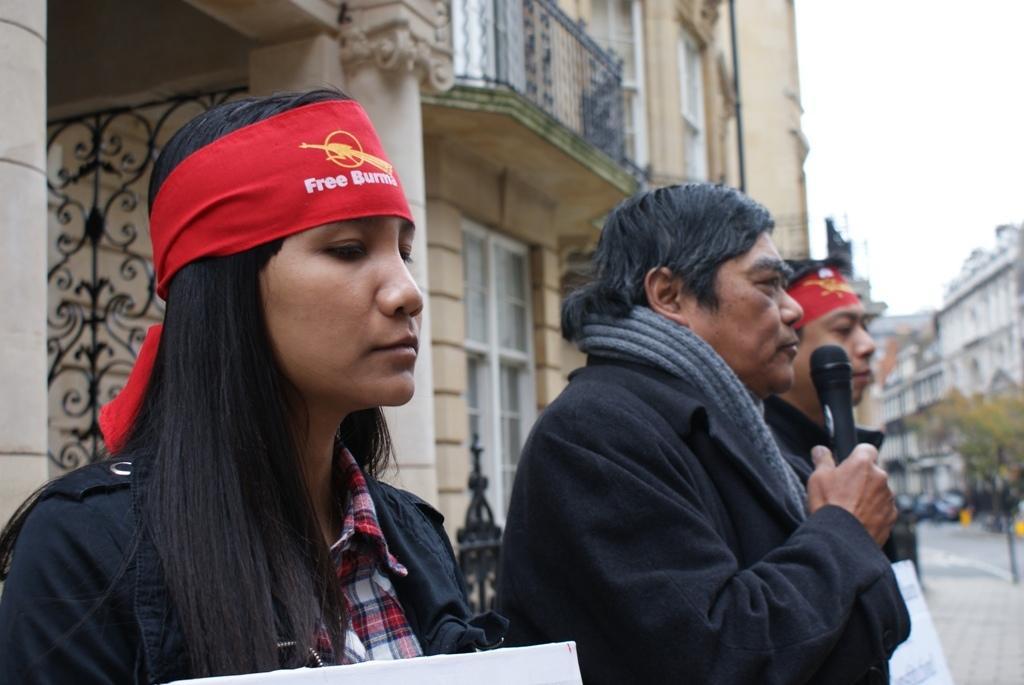In one or two sentences, can you explain what this image depicts? This is picture of the outside of the city. There are three people one,two and three. Two persons are boys and one girl. The person is holding mic. He is talking like something. The girl is wearing red color ribbon. we can see on the background there is a building,trees,roads and sky. 